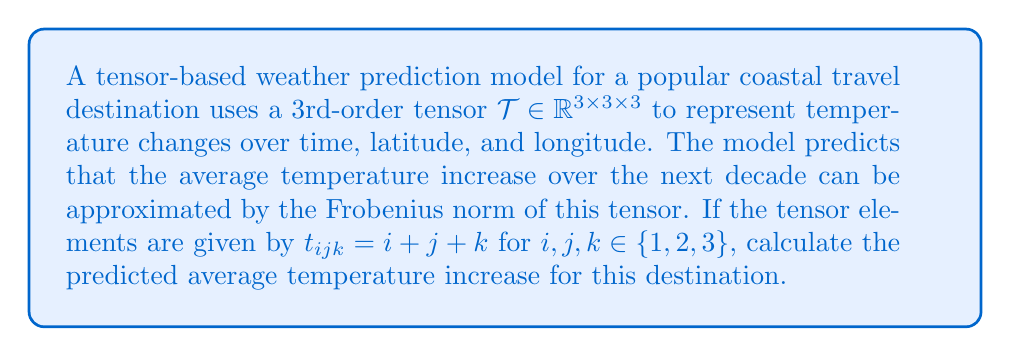Can you answer this question? Let's approach this step-by-step:

1) The Frobenius norm of a 3rd-order tensor is defined as:

   $$\|\mathcal{T}\|_F = \sqrt{\sum_{i=1}^3 \sum_{j=1}^3 \sum_{k=1}^3 |t_{ijk}|^2}$$

2) We're given that $t_{ijk} = i + j + k$ for $i,j,k \in \{1,2,3\}$. Let's calculate each element:

   $t_{111} = 1 + 1 + 1 = 3$
   $t_{112} = 1 + 1 + 2 = 4$
   $t_{113} = 1 + 1 + 3 = 5$
   $t_{121} = 1 + 2 + 1 = 4$
   ...
   $t_{333} = 3 + 3 + 3 = 9$

3) Now, we need to square each of these values and sum them:

   $3^2 + 4^2 + 5^2 + 4^2 + 5^2 + 6^2 + 5^2 + 6^2 + 7^2 +$
   $4^2 + 5^2 + 6^2 + 5^2 + 6^2 + 7^2 + 6^2 + 7^2 + 8^2 +$
   $5^2 + 6^2 + 7^2 + 6^2 + 7^2 + 8^2 + 7^2 + 8^2 + 9^2$

4) This sum equals 1240.

5) Finally, we take the square root:

   $$\|\mathcal{T}\|_F = \sqrt{1240} \approx 35.21$$

Therefore, the model predicts an average temperature increase of approximately 35.21 degrees over the next decade for this coastal destination.
Answer: 35.21 degrees 